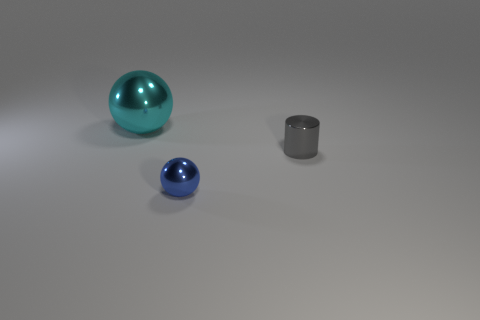Are there any other things that are the same size as the cyan metallic sphere?
Your response must be concise. No. Does the cyan thing have the same shape as the tiny blue shiny thing?
Offer a terse response. Yes. There is a shiny object that is both in front of the large metallic sphere and on the left side of the cylinder; what is its color?
Keep it short and to the point. Blue. How many tiny objects are either blue rubber objects or gray things?
Your response must be concise. 1. Are there any other things that have the same color as the large object?
Your response must be concise. No. How many matte objects are tiny gray objects or large cyan spheres?
Provide a succinct answer. 0. What number of blue objects are metal objects or tiny metal spheres?
Your answer should be compact. 1. Are there the same number of large cyan objects that are in front of the tiny ball and shiny balls behind the gray object?
Ensure brevity in your answer.  No. What shape is the metallic object that is behind the metallic object right of the tiny object left of the small gray metallic cylinder?
Ensure brevity in your answer.  Sphere. Are there more small metallic things that are in front of the gray metal cylinder than tiny green matte cylinders?
Provide a short and direct response. Yes. 